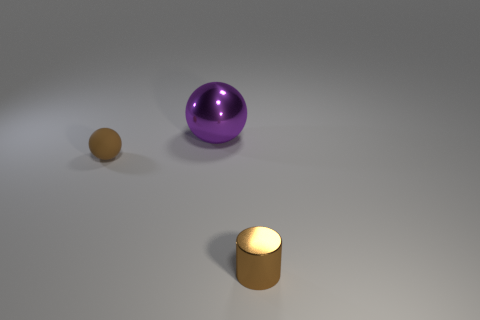How many things are brown objects right of the big shiny object or tiny things in front of the brown rubber ball?
Ensure brevity in your answer.  1. What number of other things are there of the same color as the rubber object?
Give a very brief answer. 1. Is the number of shiny spheres left of the big metallic sphere less than the number of small rubber spheres that are in front of the tiny brown metal cylinder?
Offer a terse response. No. How many metallic balls are there?
Offer a very short reply. 1. Is there any other thing that is the same material as the tiny cylinder?
Offer a terse response. Yes. What material is the big purple object that is the same shape as the small brown rubber object?
Your response must be concise. Metal. Are there fewer spheres that are right of the big shiny ball than big shiny spheres?
Your answer should be compact. Yes. Do the object that is to the right of the purple sphere and the big purple object have the same shape?
Provide a short and direct response. No. Is there any other thing that has the same color as the large metal thing?
Give a very brief answer. No. There is a purple thing that is the same material as the cylinder; what size is it?
Offer a terse response. Large. 